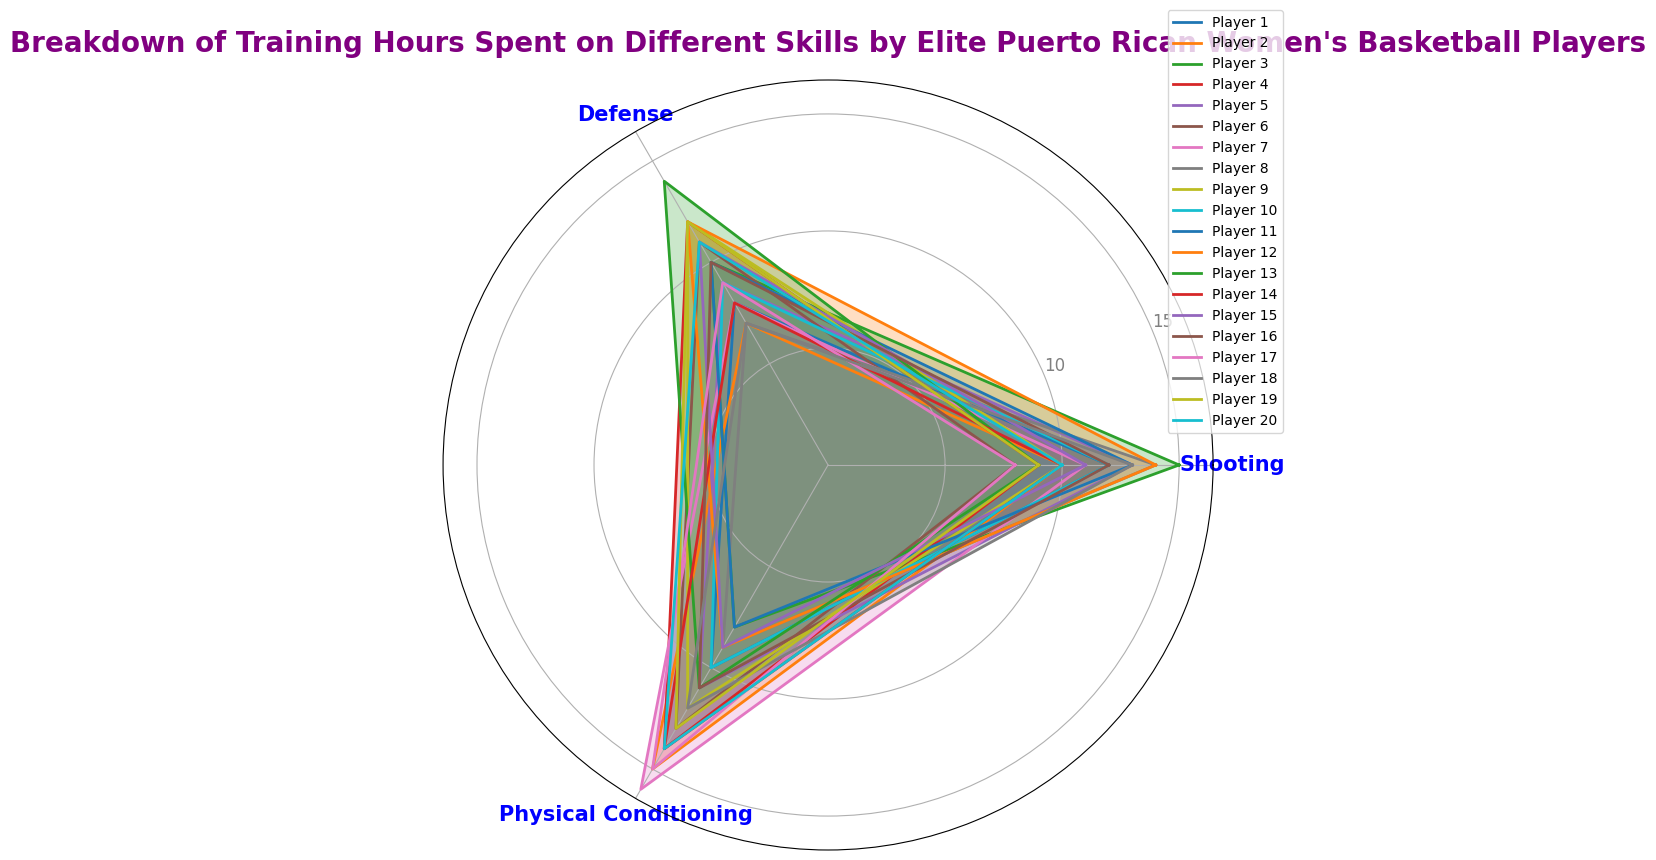What skill do players spend the most training hours on average? Calculate the average hours for each skill. Shooting: (12+10+15+9+13+8+11+14+10+12+13+14+9+10+11+12+8+13+9+10) / 20 = 11.1, Defense: (8+7+10+12+9+11+8+7+12+9+10+12+14+8+11+10+9+7+12+11) / 20 = 9.8, Physical Conditioning: (10+15+8+14+11+13+16+9+12+10+8+9+11+14+9+11+15+12+13+14) / 20 = 11.4. Physical Conditioning has the highest average.
Answer: Physical Conditioning Which player spends the least time on shooting? Find the player with the minimum shooting hours. Player 6 and Player 17 both spend 8 hours on shooting, the minimum.
Answer: Player 6 and Player 17 Which skill do Player 3 and Player 8 spend the most hours on? Compare the hours for each skill for Player 3 and Player 8. For Player 3, most hours are on Shooting (15). For Player 8, most hours are on Shooting (14).
Answer: Shooting Do most players spend more time on physical conditioning or defense? Compare the two columns for each player. Count how many times physical conditioning hours are greater than defense hours. This count is 12 times out of 20, so the majority of the players (12/20) spend more time on physical conditioning than defense.
Answer: Physical Conditioning What is the total number of training hours for Player 10? Sum the hours for Player 10. Shooting: 12, Defense: 9, Physical Conditioning: 10, so total = 12 + 9 + 10 = 31 hours.
Answer: 31 Which skill has the largest variance in training hours among players? Compute the variance for each skill. Variance for Shooting = 5.14, Defense = 4.02, Physical Conditioning = 5.68. Physical Conditioning has the largest variance.
Answer: Physical Conditioning How many players spend exactly 12 hours on defense? Count the players with 12 hours of defense: Player 4, Player 9, Player 12, Player 13, Player 19. Five players fit this criterion.
Answer: 5 Is there any player who spends exactly the same number of hours on all skills? Check each player's hours for all skills to see if they are equal. No player has equal hours for Shooting, Defense, and Physical Conditioning.
Answer: No Which skill shows the highest peak in training hours for any individual player? Identify the maximum hours recorded in any skill: Shooting (15 by Player 3), Defense (14 by Player 13), Physical Conditioning (16 by Player 7). Physical Conditioning has the highest peak.
Answer: Physical Conditioning 